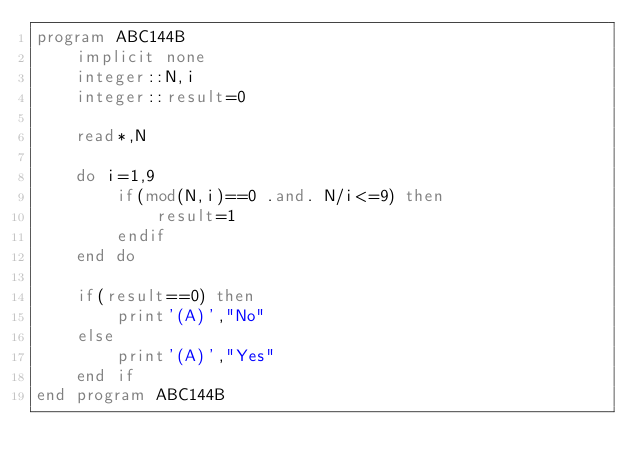Convert code to text. <code><loc_0><loc_0><loc_500><loc_500><_FORTRAN_>program ABC144B
    implicit none
    integer::N,i
    integer::result=0

    read*,N

    do i=1,9
        if(mod(N,i)==0 .and. N/i<=9) then
            result=1
        endif
    end do

    if(result==0) then
        print'(A)',"No"
    else
        print'(A)',"Yes"
    end if
end program ABC144B</code> 